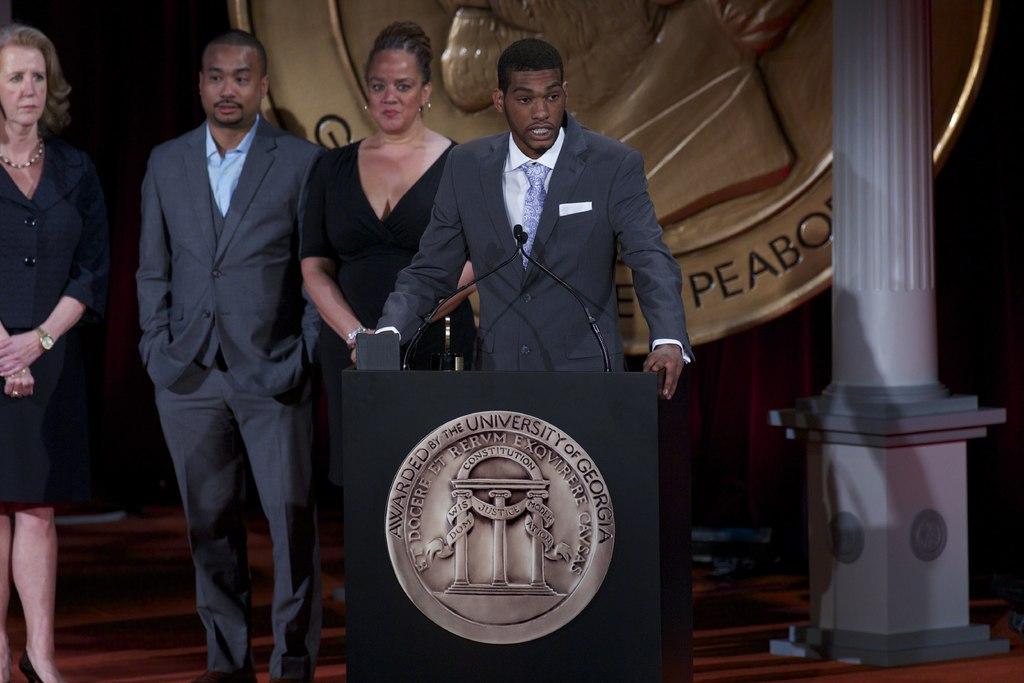What is the state?
Offer a very short reply. Georgia. 